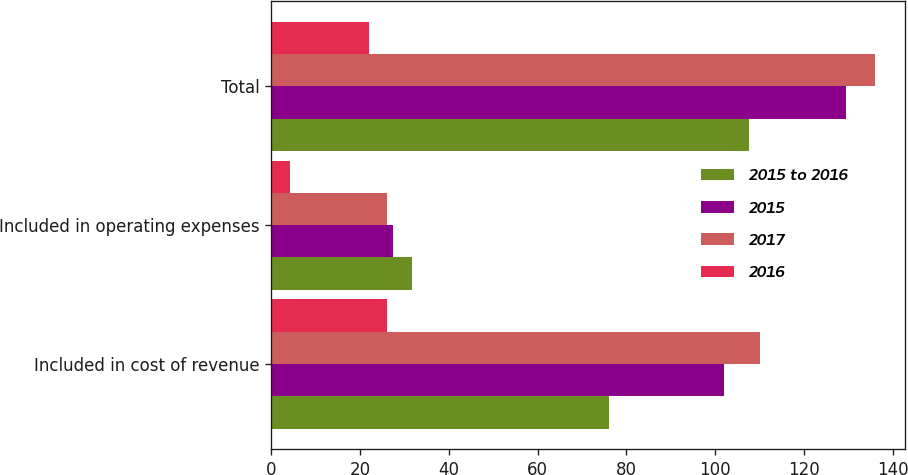Convert chart to OTSL. <chart><loc_0><loc_0><loc_500><loc_500><stacked_bar_chart><ecel><fcel>Included in cost of revenue<fcel>Included in operating expenses<fcel>Total<nl><fcel>2015 to 2016<fcel>76.1<fcel>31.6<fcel>107.7<nl><fcel>2015<fcel>102.1<fcel>27.5<fcel>129.6<nl><fcel>2017<fcel>110<fcel>26<fcel>136<nl><fcel>2016<fcel>26<fcel>4.1<fcel>21.9<nl></chart> 